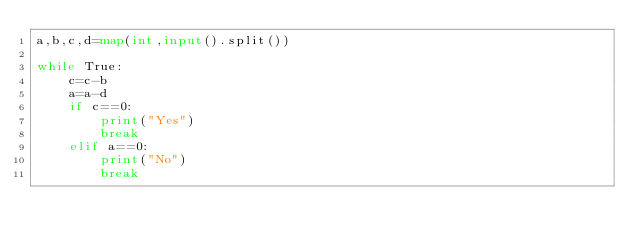<code> <loc_0><loc_0><loc_500><loc_500><_Python_>a,b,c,d=map(int,input().split())

while True:
    c=c-b
    a=a-d
    if c==0:
        print("Yes")
        break
    elif a==0:
        print("No")
        break</code> 